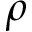<formula> <loc_0><loc_0><loc_500><loc_500>\rho</formula> 